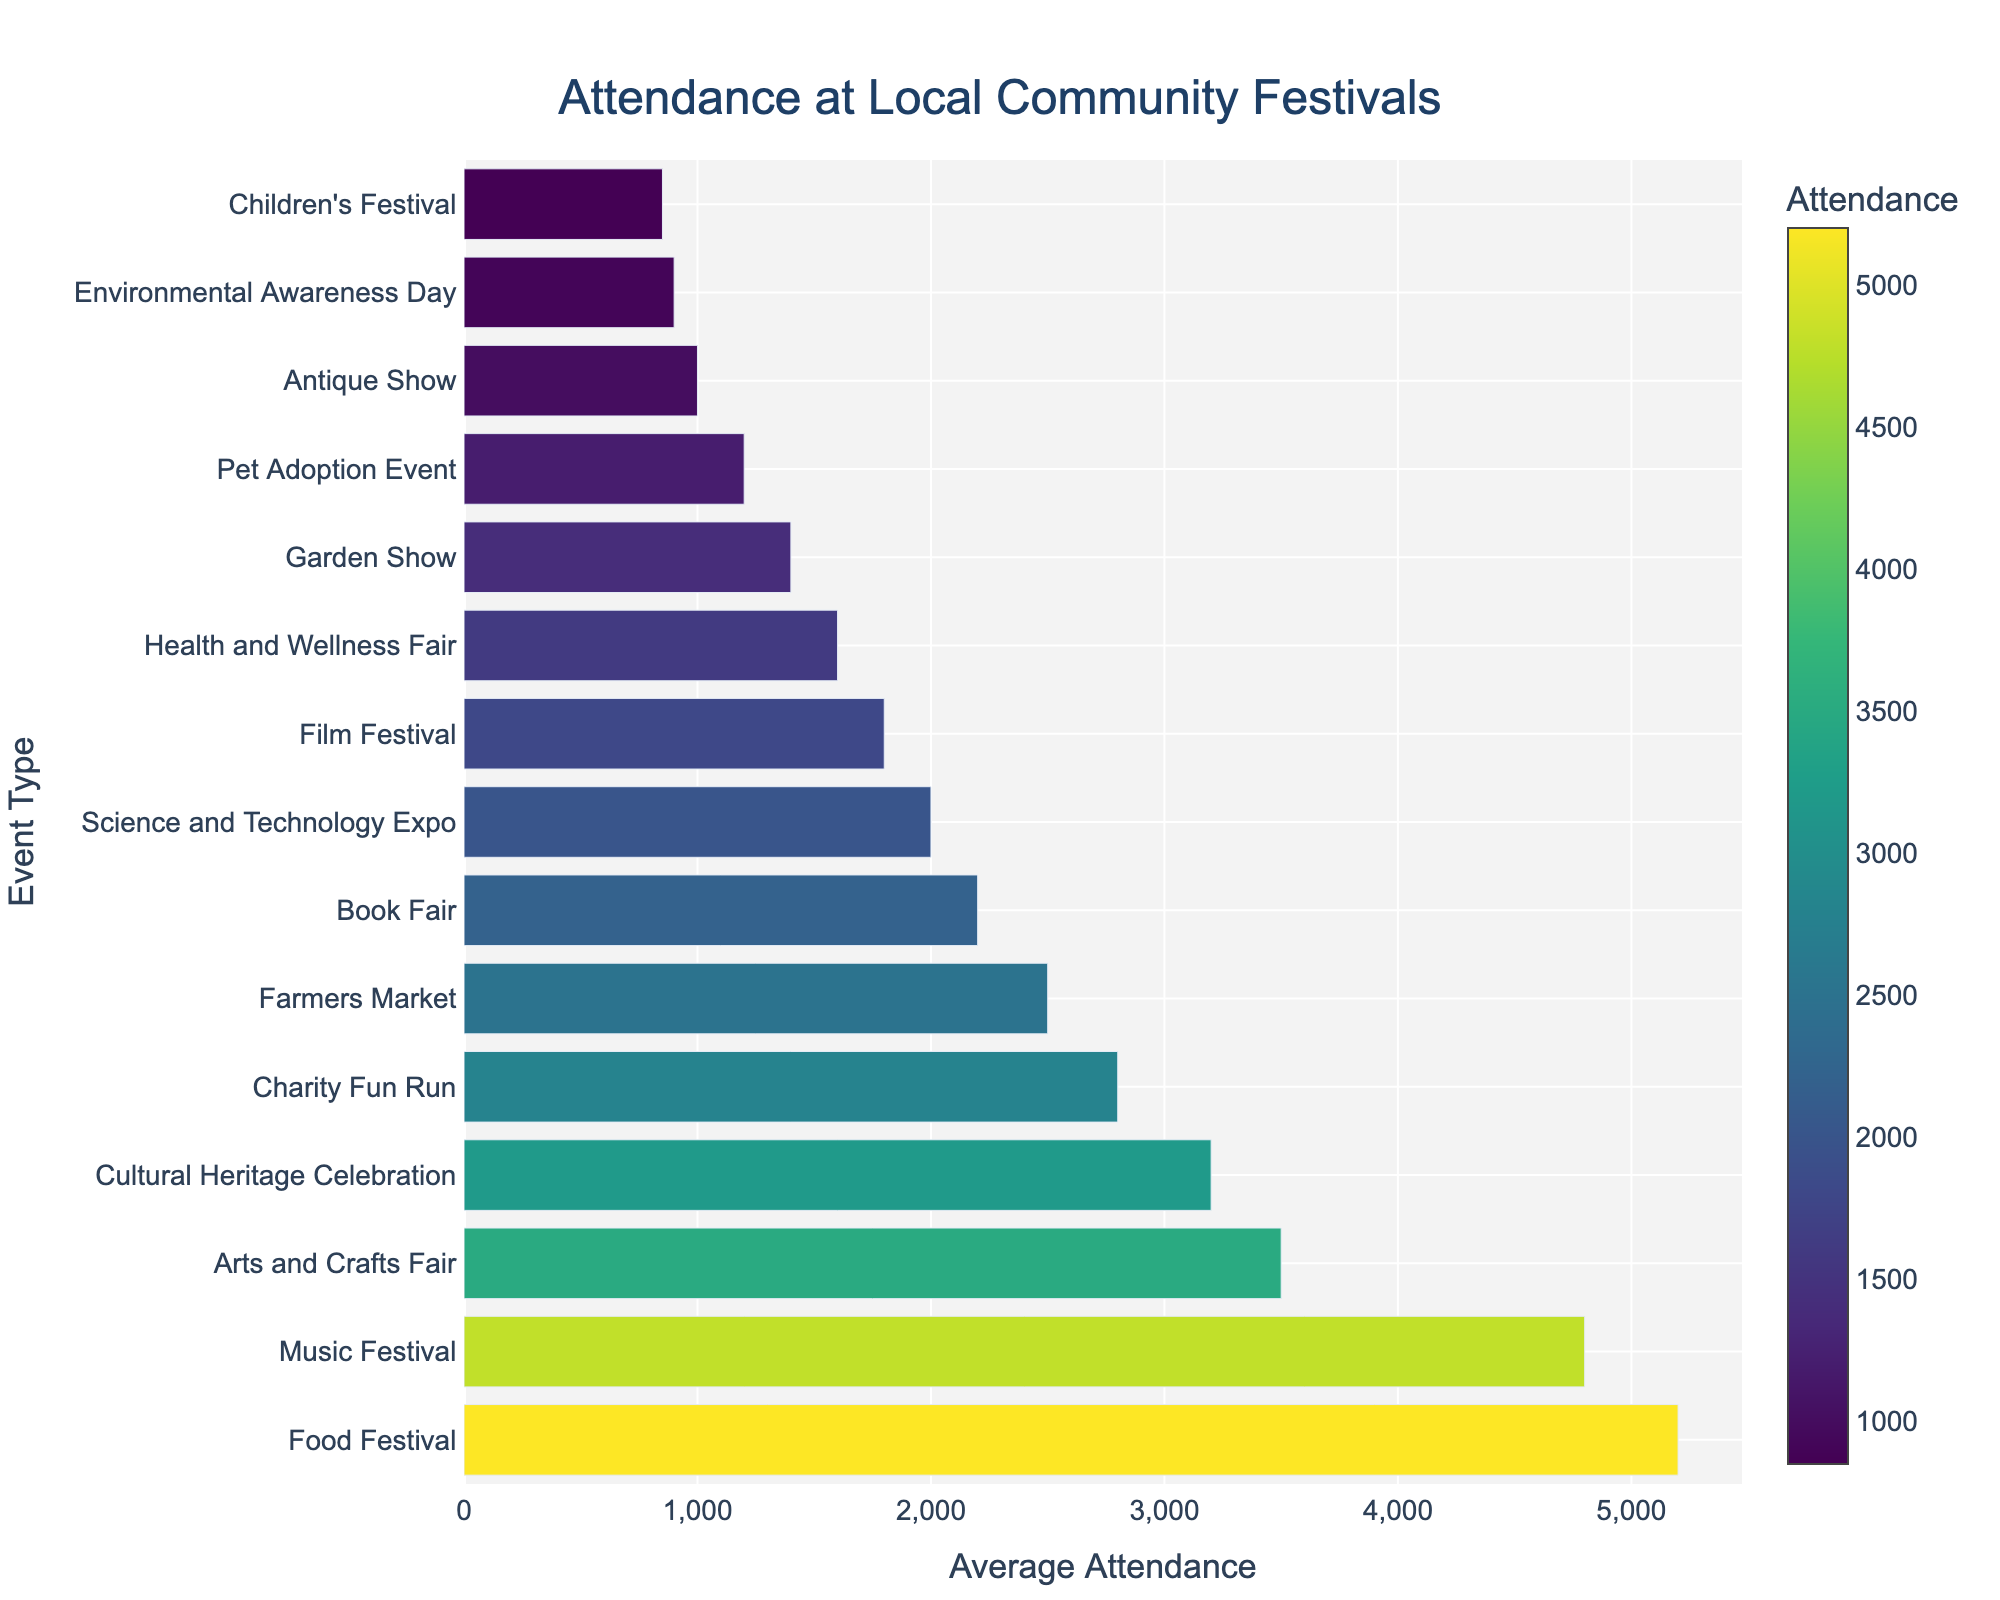Which event has the highest average attendance? Look for the bar with the greatest length in the figure. It represents the Food Festival, which has the highest average attendance.
Answer: Food Festival Which events have more than 4000 average attendance? Identify bars that extend past the 4000 mark on the x-axis. These are Food Festival and Music Festival.
Answer: Food Festival, Music Festival What's the difference in average attendance between the highest and lowest attended events? The highest attended event is the Food Festival with 5200 attendees, and the lowest is the Children's Festival with 850 attendees. The difference is 5200 - 850.
Answer: 4350 Among the events, which has the closest average attendance to 3000? Locate the bars around the 3000 mark on the x-axis. The Cultural Heritage Celebration, with an attendance of 3200, is closest to 3000.
Answer: Cultural Heritage Celebration How many events have an average attendance below 2000? Count the bars that do not extend past the 2000 mark on the x-axis. These events are Science and Technology Expo, Film Festival, Health and Wellness Fair, Garden Show, Pet Adoption Event, Antique Show, Environmental Awareness Day, and Children's Festival.
Answer: 8 Which event has just above half the attendance of the highest attended event? The highest attended event is the Food Festival with 5200 attendees, half of which is 2600. The Farmers Market, with 2500 attendees, is just below that, so look for one just above it, which is the Charity Fun Run with 2800 attendees.
Answer: Charity Fun Run Combine the average attendance of the Book Fair and the Film Festival. The attendance for Book Fair is 2200 and for Film Festival is 1800. Summing them gives 2200 + 1800.
Answer: 4000 Is there any event type that has an average attendance equal to or above 2500 but less than 3000? Find bars that start at 2500 and end before 3000 on the x-axis. The only event type that fits this range is the Farmers Market, with an attendance of 2500.
Answer: Farmers Market Compare the average attendance between the Music Festival and the Health and Wellness Fair. Which one has more attendees? Look at the length of the bars for Music Festival and Health and Wellness Fair. The Music Festival has more attendees (4800) compared to the Health and Wellness Fair (1600).
Answer: Music Festival What's the average attendance for the three lowest attended events combined? The three events with the lowest attendance are Antique Show (1000), Environmental Awareness Day (900), and Children's Festival (850). Summing these gives 1000 + 900 + 850. The combined average is (1000 + 900 + 850) / 3.
Answer: 917 